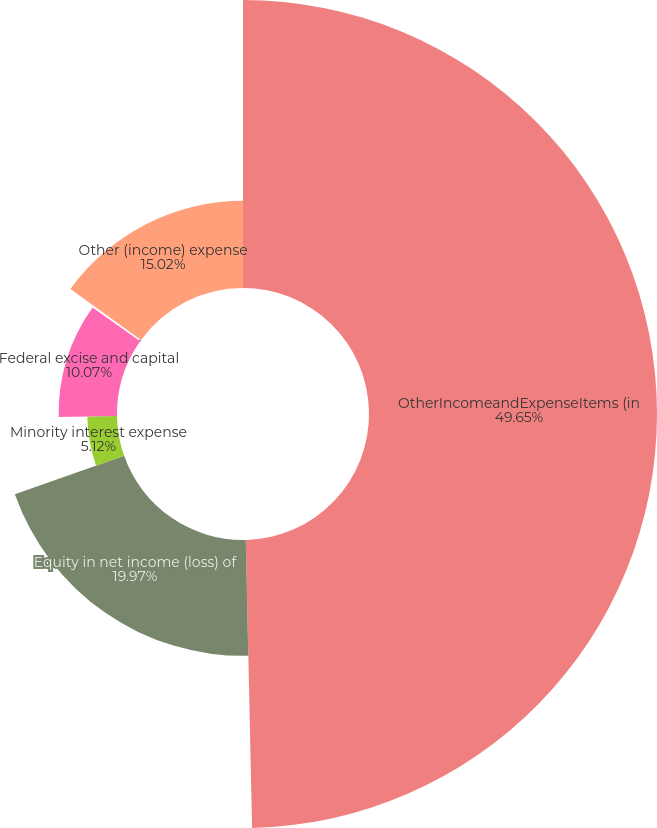<chart> <loc_0><loc_0><loc_500><loc_500><pie_chart><fcel>OtherIncomeandExpenseItems (in<fcel>Equity in net income (loss) of<fcel>Minority interest expense<fcel>Federal excise and capital<fcel>Other<fcel>Other (income) expense<nl><fcel>49.65%<fcel>19.97%<fcel>5.12%<fcel>10.07%<fcel>0.17%<fcel>15.02%<nl></chart> 